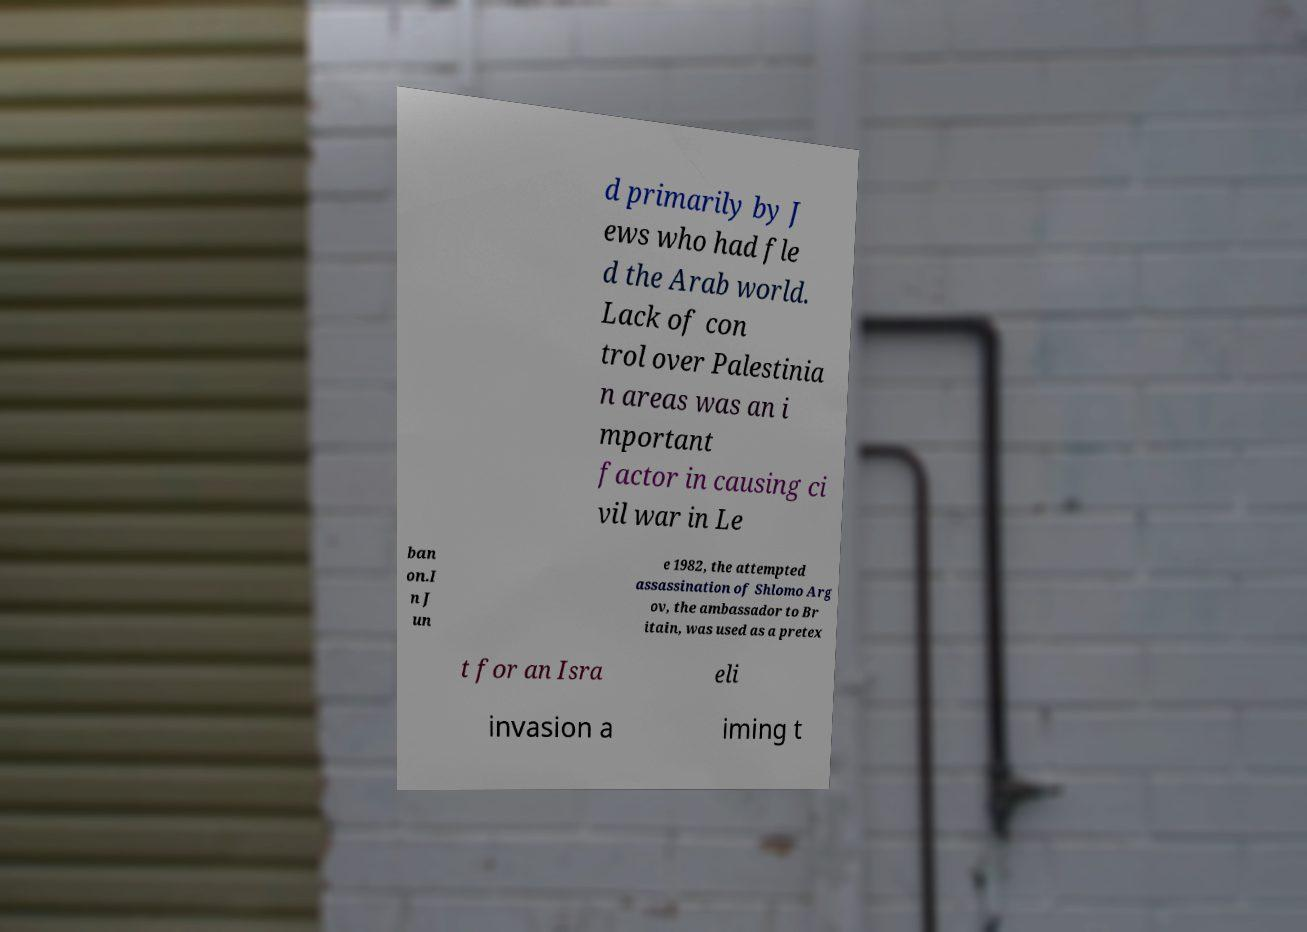Could you assist in decoding the text presented in this image and type it out clearly? d primarily by J ews who had fle d the Arab world. Lack of con trol over Palestinia n areas was an i mportant factor in causing ci vil war in Le ban on.I n J un e 1982, the attempted assassination of Shlomo Arg ov, the ambassador to Br itain, was used as a pretex t for an Isra eli invasion a iming t 